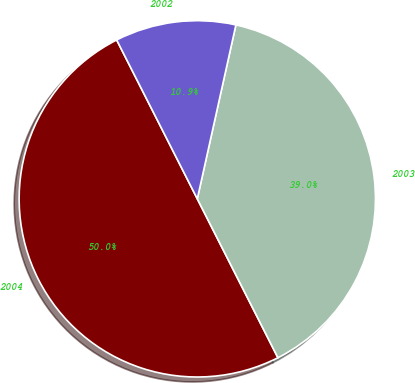<chart> <loc_0><loc_0><loc_500><loc_500><pie_chart><fcel>2004<fcel>2003<fcel>2002<nl><fcel>50.0%<fcel>39.05%<fcel>10.95%<nl></chart> 